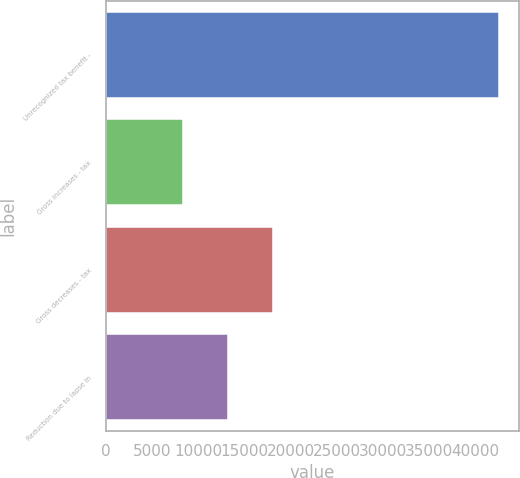Convert chart. <chart><loc_0><loc_0><loc_500><loc_500><bar_chart><fcel>Unrecognized tax benefit -<fcel>Gross increases - tax<fcel>Gross decreases - tax<fcel>Reduction due to lapse in<nl><fcel>42594<fcel>8305.5<fcel>18094.5<fcel>13200<nl></chart> 